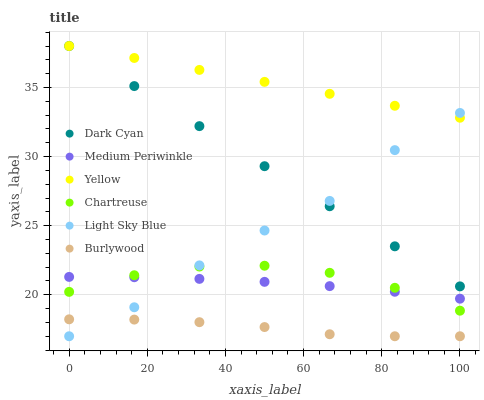Does Burlywood have the minimum area under the curve?
Answer yes or no. Yes. Does Yellow have the maximum area under the curve?
Answer yes or no. Yes. Does Medium Periwinkle have the minimum area under the curve?
Answer yes or no. No. Does Medium Periwinkle have the maximum area under the curve?
Answer yes or no. No. Is Dark Cyan the smoothest?
Answer yes or no. Yes. Is Light Sky Blue the roughest?
Answer yes or no. Yes. Is Medium Periwinkle the smoothest?
Answer yes or no. No. Is Medium Periwinkle the roughest?
Answer yes or no. No. Does Burlywood have the lowest value?
Answer yes or no. Yes. Does Medium Periwinkle have the lowest value?
Answer yes or no. No. Does Dark Cyan have the highest value?
Answer yes or no. Yes. Does Medium Periwinkle have the highest value?
Answer yes or no. No. Is Chartreuse less than Yellow?
Answer yes or no. Yes. Is Dark Cyan greater than Medium Periwinkle?
Answer yes or no. Yes. Does Yellow intersect Dark Cyan?
Answer yes or no. Yes. Is Yellow less than Dark Cyan?
Answer yes or no. No. Is Yellow greater than Dark Cyan?
Answer yes or no. No. Does Chartreuse intersect Yellow?
Answer yes or no. No. 